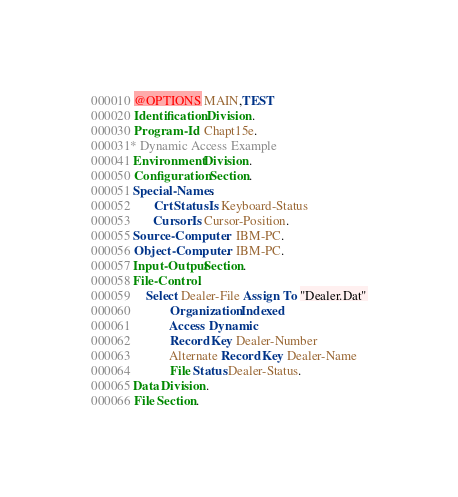<code> <loc_0><loc_0><loc_500><loc_500><_COBOL_>000010 @OPTIONS MAIN,TEST
000020 Identification Division.
000030 Program-Id.  Chapt15e.
000031* Dynamic Access Example
000041 Environment Division.
000050 Configuration Section.
000051 Special-Names.
000052       Crt Status Is Keyboard-Status
000053       Cursor Is Cursor-Position.
000055 Source-Computer.  IBM-PC.
000056 Object-Computer.  IBM-PC.
000057 Input-Output Section.
000058 File-Control.
000059     Select Dealer-File Assign To "Dealer.Dat"
000060            Organization Indexed
000061            Access Dynamic
000062            Record Key Dealer-Number
000063            Alternate Record Key Dealer-Name
000064            File Status Dealer-Status.
000065 Data Division.
000066 File Section.</code> 